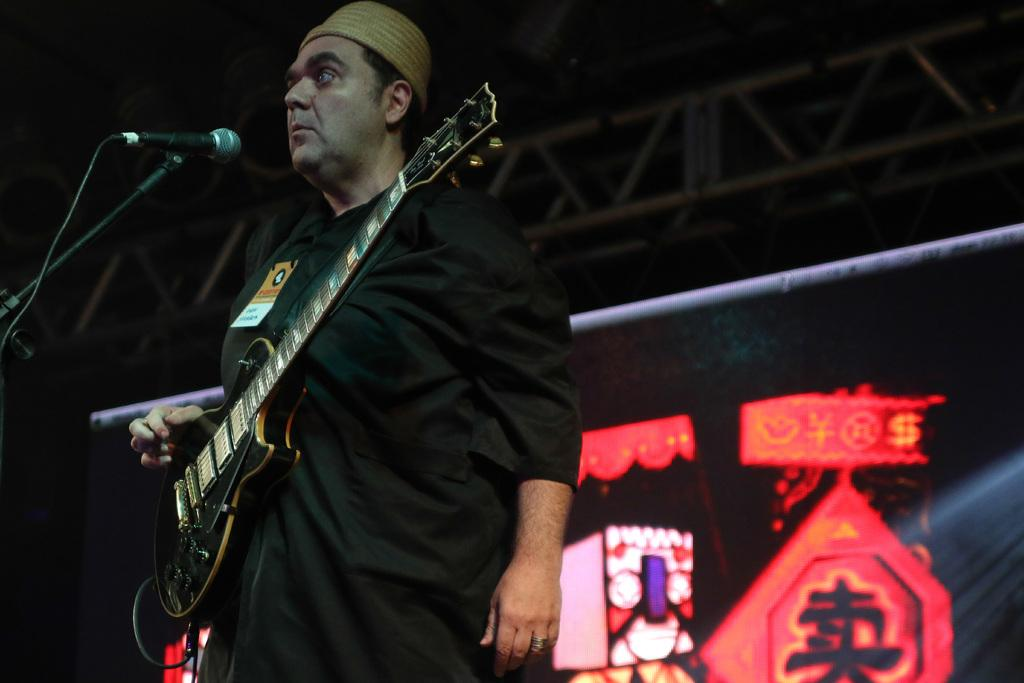What is the man in the image doing? The man is standing in the image. What is the man wearing in the image? The man is wearing a guitar. What object is near the man in the image? The man is near a microphone. What can be seen in the background of the image? There is a banner in the background of the image. What type of juice is being served to the pig in the image? There is no pig or juice present in the image. What type of destruction can be seen in the image? There is no destruction present in the image. 